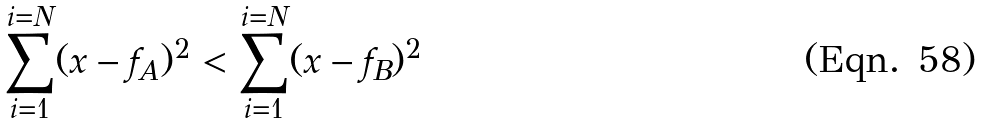Convert formula to latex. <formula><loc_0><loc_0><loc_500><loc_500>\sum _ { i = 1 } ^ { i = N } ( x - f _ { A } ) ^ { 2 } < \sum _ { i = 1 } ^ { i = N } ( x - f _ { B } ) ^ { 2 }</formula> 